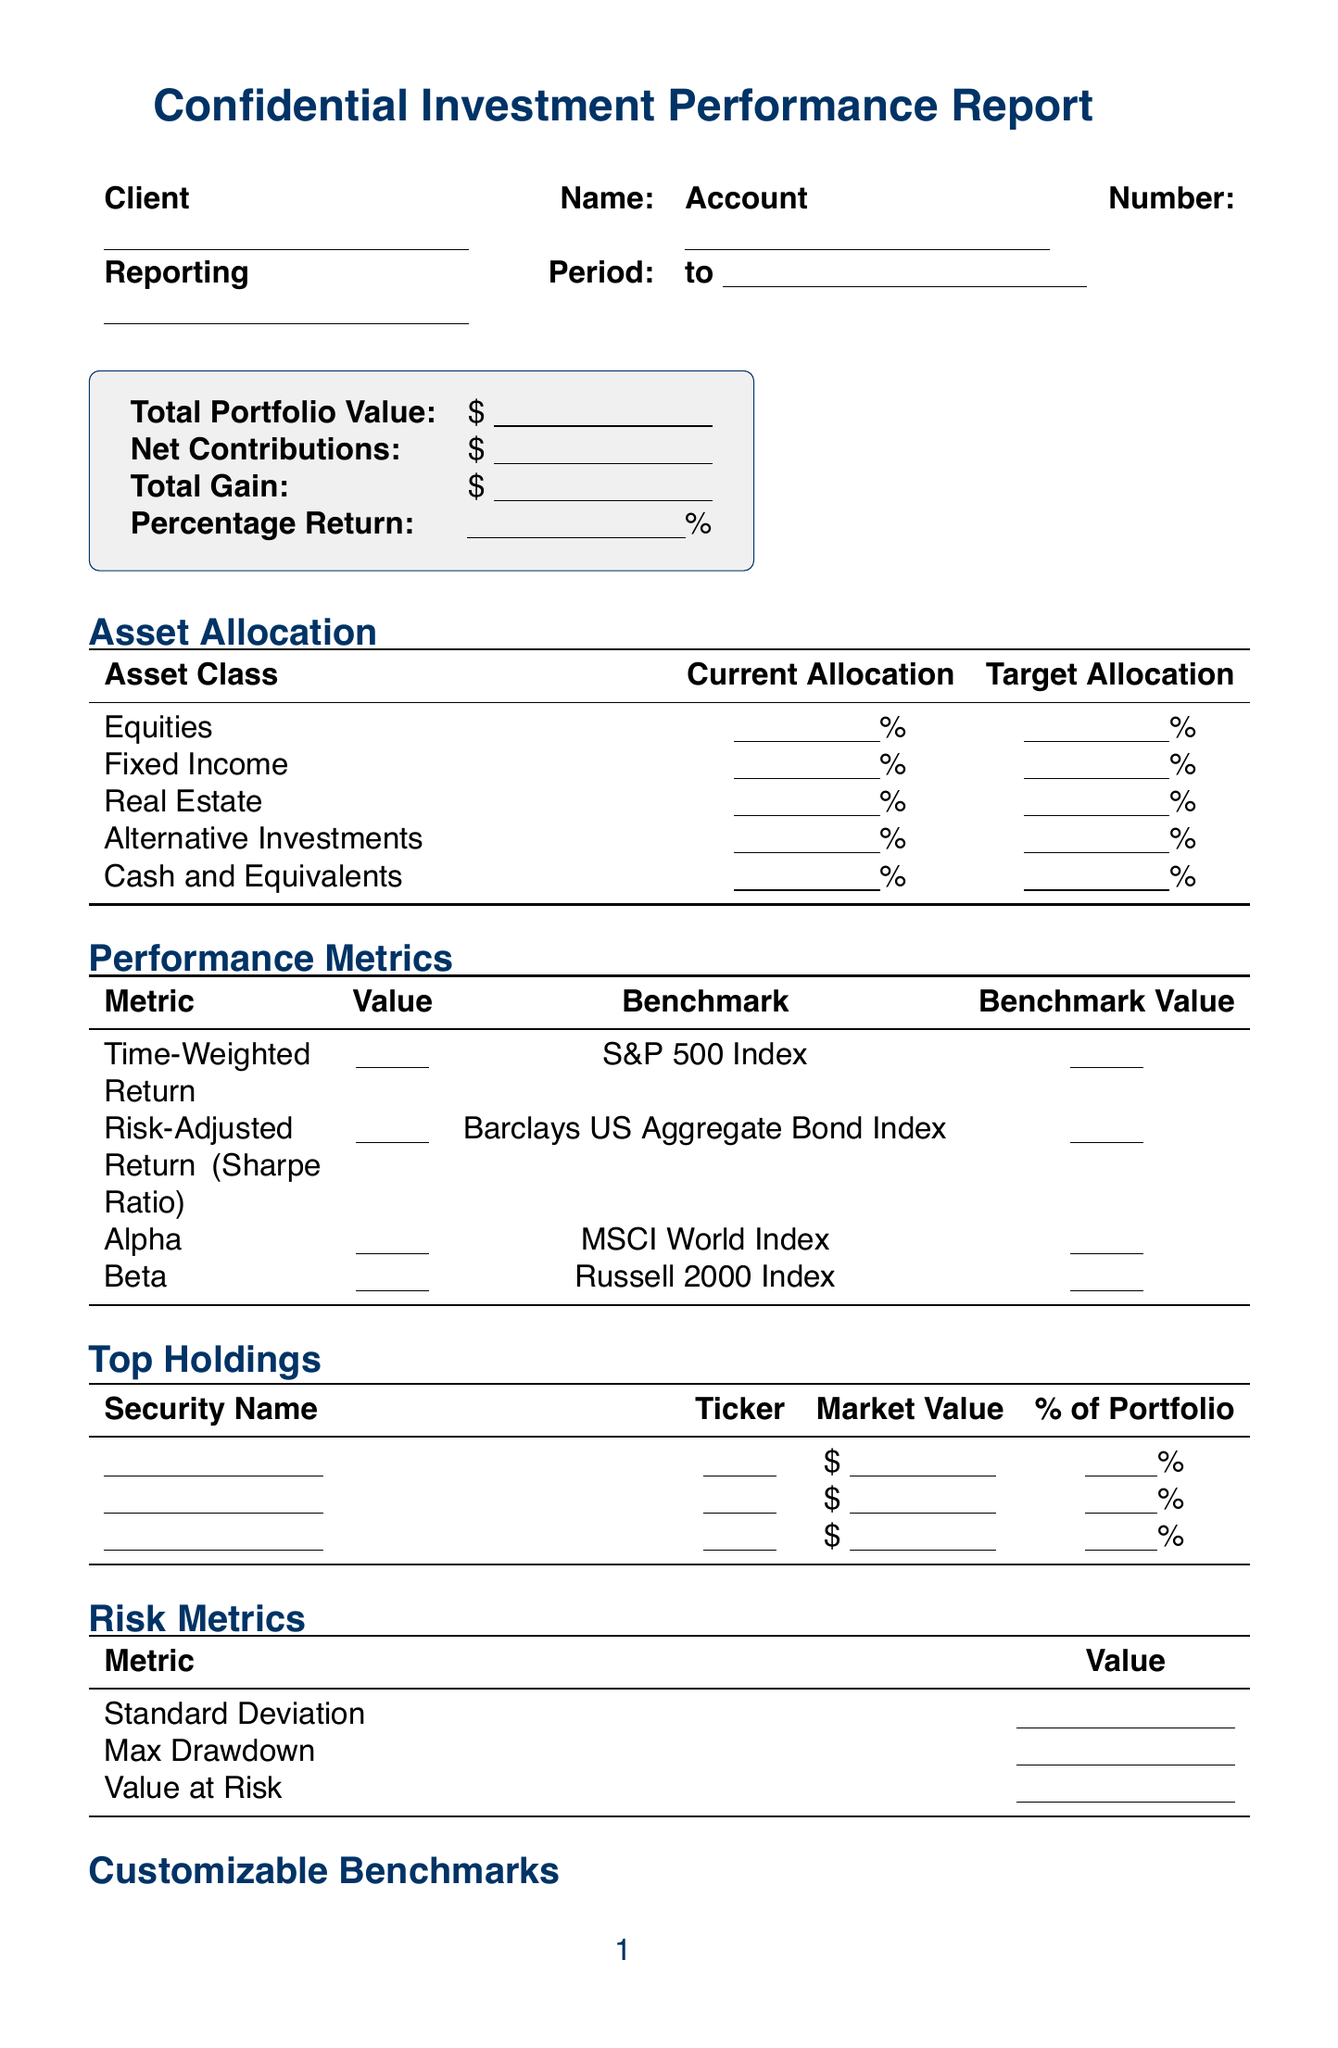What is the client name? The client name is mentioned in the document under client information.
Answer: [Name] What is the total portfolio value? The total portfolio value is specified in the portfolio summary section as a monetary amount.
Answer: $[Value] What is the percentage return? The percentage return is calculated and found in the portfolio summary, representing the performance outcome.
Answer: [Percentage]% What is the current allocation for Equities? The current allocation for Equities is provided in the asset allocation section of the report.
Answer: [Percentage]% What is the benchmark for Time-Weighted Return? The benchmark for Time-Weighted Return is listed in the performance metrics section, indicating a comparison metric.
Answer: S&P 500 Index What is the value at risk? The value at risk is provided in the risk metrics section of the document, showing the potential loss in value.
Answer: [Value] What is the contribution of asset allocation to performance attribution? The contribution of asset allocation is found in the performance attribution section, indicating its impact on returns.
Answer: [Value] How many asset classes are included in the asset allocation? The number of asset classes is determined by counting each category listed in the asset allocation section.
Answer: 5 What is the overall ESG score? The overall ESG score is located in the ESG metrics section, reflecting the performance on environmental, social, and governance criteria.
Answer: [Score] What is the date range of the reporting period? The reporting period is specified in the client information section, indicating the timeframe of the report.
Answer: [Start Date] to [End Date] 